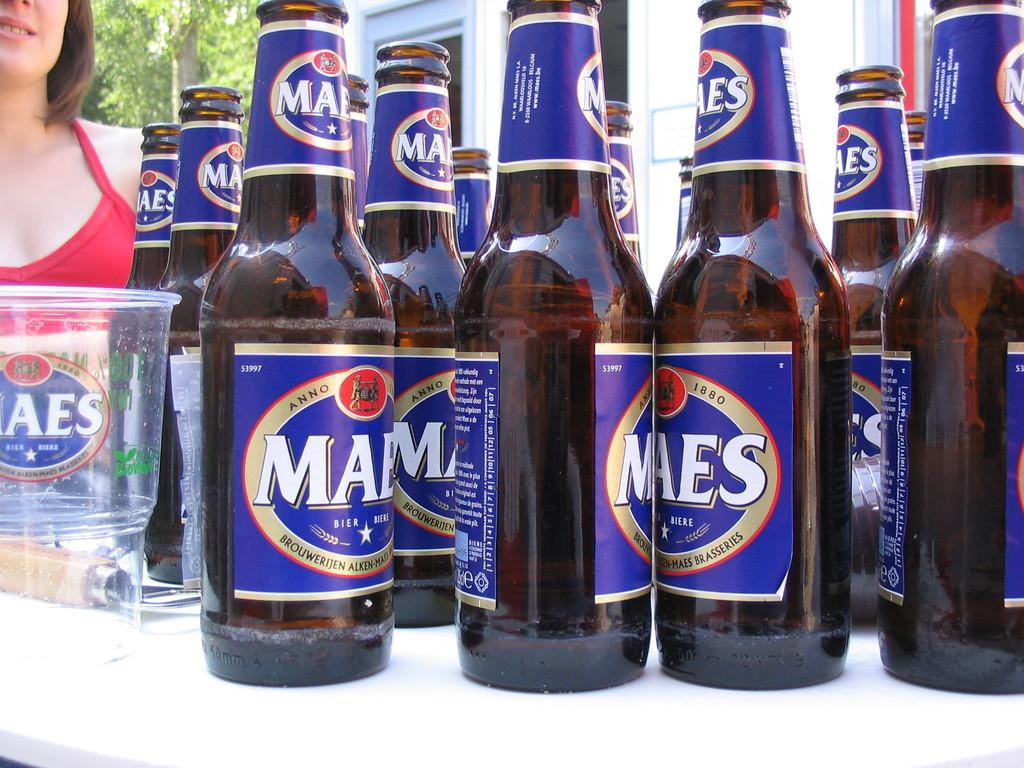<image>
Offer a succinct explanation of the picture presented. Eleven bottles of Maes beer Brouwerijen alken-maes brasseries 